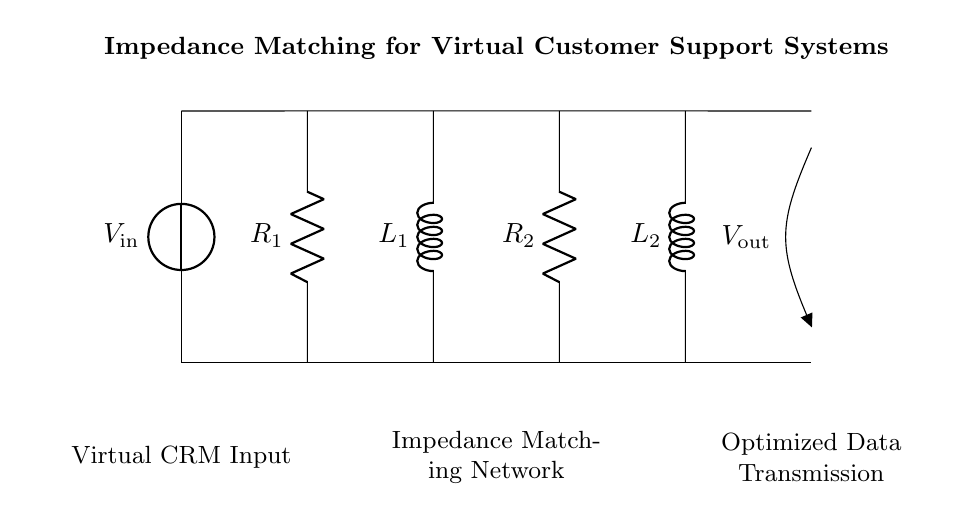What is the voltage source in the circuit? The voltage source is indicated as \( V_\text{in} \) at the left side of the circuit diagram. It provides the input voltage for the entire circuit.
Answer: \( V_\text{in} \) What are the two types of components used in the circuit? The components used in the circuit mainly consist of resistors and inductors. These are indicated by \( R_1 \), \( R_2 \) for resistors, and \( L_1 \), \( L_2 \) for inductors, as labeled above each component.
Answer: Resistors and inductors Which part of the circuit is designated for data input? The left section of the circuit, labeled "Virtual CRM Input," corresponds to the input voltage source and represents the point where data is fed into the system.
Answer: Virtual CRM Input What is the function of the impedance matching network in this circuit? The impedance matching network, made up of the series and parallel combinations of resistors and inductors, optimizes the power transfer from the input to the output by minimizing reflection losses, ensuring efficient data transmission.
Answer: Optimize power transfer How many inductors are present in the impedance matching network? There are two inductors denoted in the circuit as \( L_1 \) and \( L_2 \), as represented in the middle section of the circuit diagram.
Answer: Two What is the purpose of having multiple resistors in series in the circuit? The two resistors \( R_1 \) and \( R_2 \) are likely utilized in combination to adjust the total resistance for optimal impedance matching, ensuring the input and output impedances are suitably balanced for maximum signal integrity.
Answer: Adjust resistance for matching Which component is located furthest right in the circuit? The component located furthest right in the circuit is expressed as \( V_\text{out} \), which represents the output voltage of the circuit after passing through the impedance matching network.
Answer: \( V_\text{out} \) 